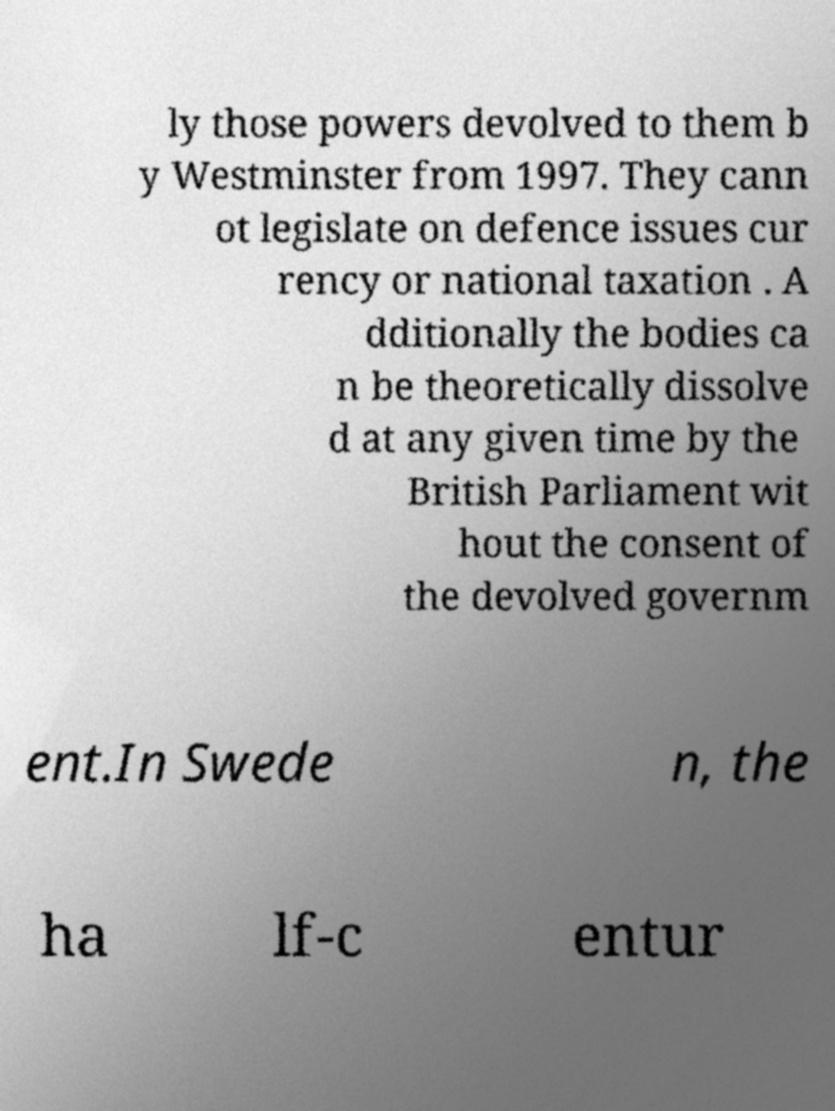Please identify and transcribe the text found in this image. ly those powers devolved to them b y Westminster from 1997. They cann ot legislate on defence issues cur rency or national taxation . A dditionally the bodies ca n be theoretically dissolve d at any given time by the British Parliament wit hout the consent of the devolved governm ent.In Swede n, the ha lf-c entur 